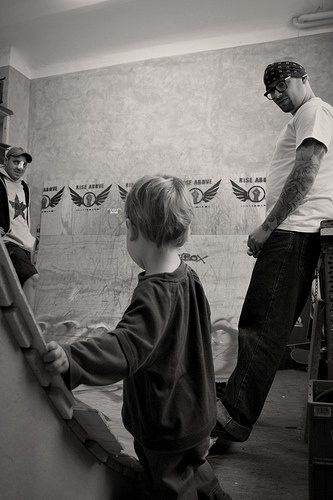Describe the objects in this image and their specific colors. I can see people in gray, black, and darkgray tones, people in gray, black, darkgray, and lightgray tones, and people in gray, black, and darkgray tones in this image. 